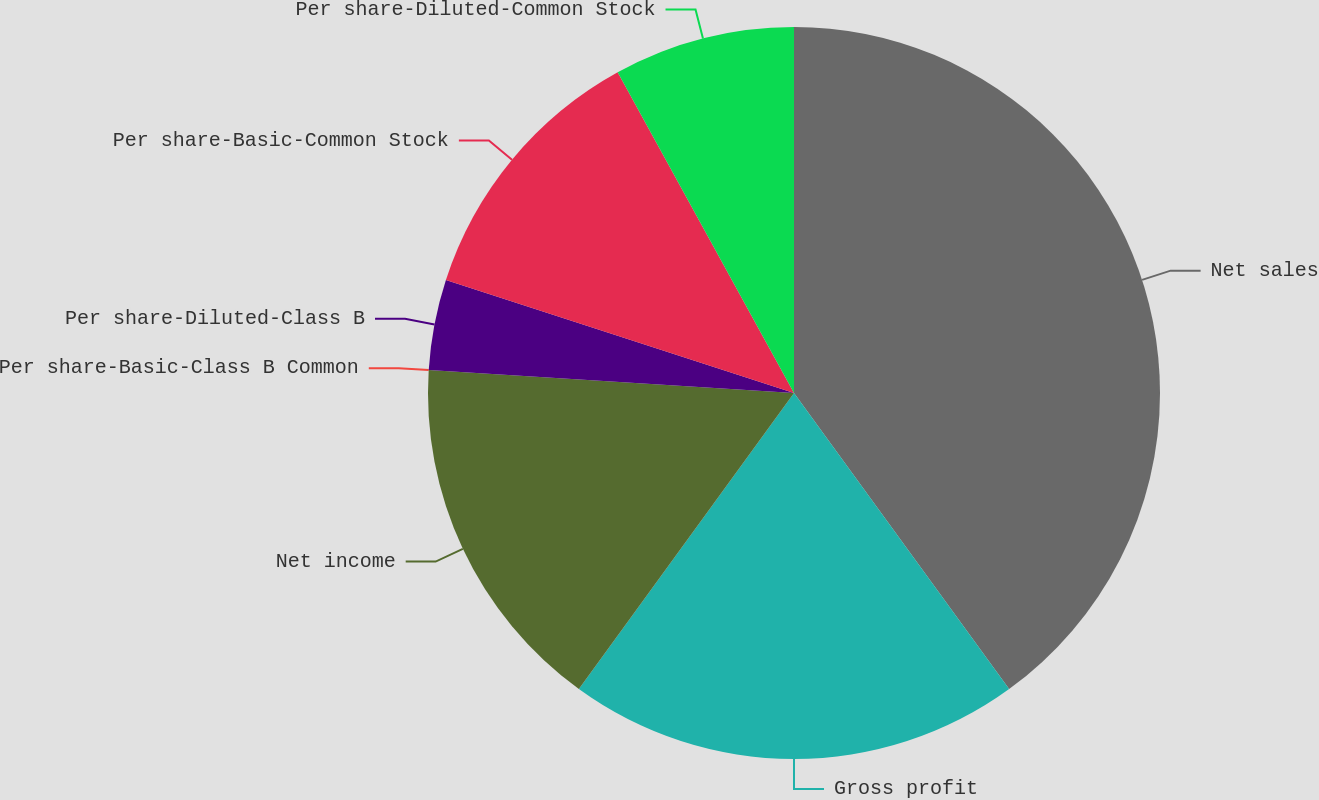Convert chart. <chart><loc_0><loc_0><loc_500><loc_500><pie_chart><fcel>Net sales<fcel>Gross profit<fcel>Net income<fcel>Per share-Basic-Class B Common<fcel>Per share-Diluted-Class B<fcel>Per share-Basic-Common Stock<fcel>Per share-Diluted-Common Stock<nl><fcel>40.0%<fcel>20.0%<fcel>16.0%<fcel>0.0%<fcel>4.0%<fcel>12.0%<fcel>8.0%<nl></chart> 